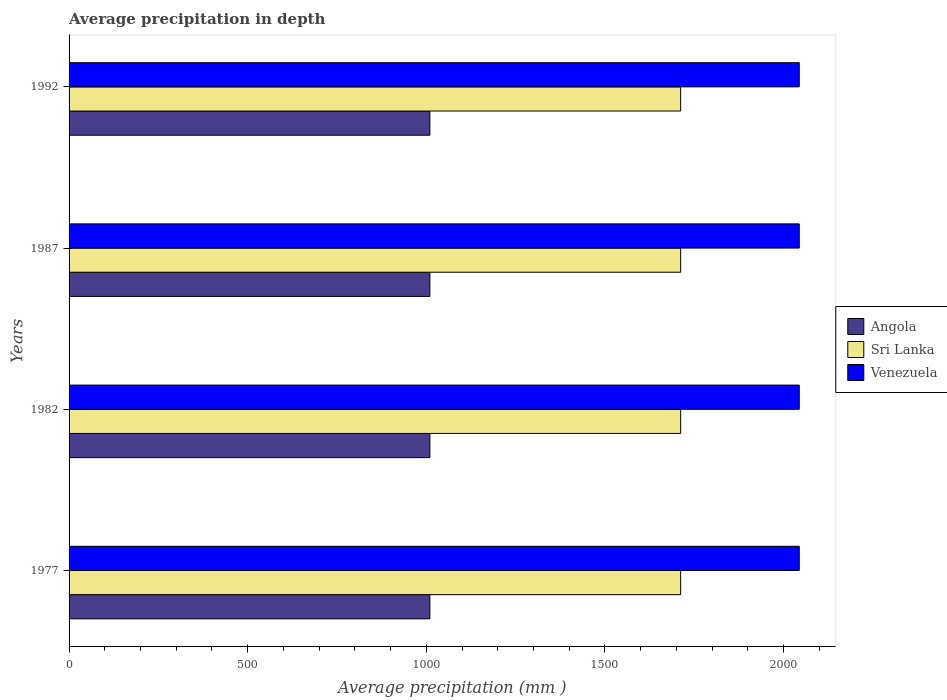How many different coloured bars are there?
Your answer should be very brief. 3. How many groups of bars are there?
Your response must be concise. 4. Are the number of bars per tick equal to the number of legend labels?
Give a very brief answer. Yes. How many bars are there on the 2nd tick from the top?
Offer a terse response. 3. How many bars are there on the 2nd tick from the bottom?
Ensure brevity in your answer.  3. What is the label of the 3rd group of bars from the top?
Give a very brief answer. 1982. What is the average precipitation in Venezuela in 1977?
Provide a succinct answer. 2044. Across all years, what is the maximum average precipitation in Angola?
Ensure brevity in your answer.  1010. Across all years, what is the minimum average precipitation in Venezuela?
Offer a very short reply. 2044. What is the total average precipitation in Sri Lanka in the graph?
Provide a succinct answer. 6848. What is the difference between the average precipitation in Angola in 1982 and that in 1987?
Ensure brevity in your answer.  0. What is the difference between the average precipitation in Sri Lanka in 1992 and the average precipitation in Angola in 1982?
Your response must be concise. 702. What is the average average precipitation in Venezuela per year?
Your response must be concise. 2044. In the year 1977, what is the difference between the average precipitation in Venezuela and average precipitation in Angola?
Your answer should be compact. 1034. In how many years, is the average precipitation in Sri Lanka greater than 200 mm?
Ensure brevity in your answer.  4. Is the average precipitation in Angola in 1987 less than that in 1992?
Give a very brief answer. No. What does the 1st bar from the top in 1992 represents?
Ensure brevity in your answer.  Venezuela. What does the 1st bar from the bottom in 1982 represents?
Ensure brevity in your answer.  Angola. Is it the case that in every year, the sum of the average precipitation in Angola and average precipitation in Venezuela is greater than the average precipitation in Sri Lanka?
Offer a very short reply. Yes. How many years are there in the graph?
Your answer should be compact. 4. What is the difference between two consecutive major ticks on the X-axis?
Ensure brevity in your answer.  500. Are the values on the major ticks of X-axis written in scientific E-notation?
Your response must be concise. No. Does the graph contain grids?
Your response must be concise. No. How many legend labels are there?
Offer a terse response. 3. What is the title of the graph?
Offer a terse response. Average precipitation in depth. What is the label or title of the X-axis?
Your answer should be very brief. Average precipitation (mm ). What is the label or title of the Y-axis?
Ensure brevity in your answer.  Years. What is the Average precipitation (mm ) of Angola in 1977?
Ensure brevity in your answer.  1010. What is the Average precipitation (mm ) of Sri Lanka in 1977?
Make the answer very short. 1712. What is the Average precipitation (mm ) in Venezuela in 1977?
Make the answer very short. 2044. What is the Average precipitation (mm ) in Angola in 1982?
Your response must be concise. 1010. What is the Average precipitation (mm ) in Sri Lanka in 1982?
Offer a very short reply. 1712. What is the Average precipitation (mm ) in Venezuela in 1982?
Your response must be concise. 2044. What is the Average precipitation (mm ) in Angola in 1987?
Provide a succinct answer. 1010. What is the Average precipitation (mm ) of Sri Lanka in 1987?
Your answer should be very brief. 1712. What is the Average precipitation (mm ) in Venezuela in 1987?
Your answer should be compact. 2044. What is the Average precipitation (mm ) in Angola in 1992?
Provide a short and direct response. 1010. What is the Average precipitation (mm ) of Sri Lanka in 1992?
Provide a short and direct response. 1712. What is the Average precipitation (mm ) in Venezuela in 1992?
Keep it short and to the point. 2044. Across all years, what is the maximum Average precipitation (mm ) of Angola?
Provide a short and direct response. 1010. Across all years, what is the maximum Average precipitation (mm ) in Sri Lanka?
Offer a very short reply. 1712. Across all years, what is the maximum Average precipitation (mm ) in Venezuela?
Your response must be concise. 2044. Across all years, what is the minimum Average precipitation (mm ) in Angola?
Give a very brief answer. 1010. Across all years, what is the minimum Average precipitation (mm ) of Sri Lanka?
Offer a very short reply. 1712. Across all years, what is the minimum Average precipitation (mm ) in Venezuela?
Your answer should be very brief. 2044. What is the total Average precipitation (mm ) of Angola in the graph?
Offer a terse response. 4040. What is the total Average precipitation (mm ) in Sri Lanka in the graph?
Make the answer very short. 6848. What is the total Average precipitation (mm ) in Venezuela in the graph?
Keep it short and to the point. 8176. What is the difference between the Average precipitation (mm ) in Venezuela in 1977 and that in 1982?
Your response must be concise. 0. What is the difference between the Average precipitation (mm ) of Angola in 1977 and that in 1987?
Your answer should be very brief. 0. What is the difference between the Average precipitation (mm ) of Venezuela in 1977 and that in 1987?
Your answer should be very brief. 0. What is the difference between the Average precipitation (mm ) of Venezuela in 1977 and that in 1992?
Your answer should be very brief. 0. What is the difference between the Average precipitation (mm ) in Sri Lanka in 1982 and that in 1992?
Your answer should be compact. 0. What is the difference between the Average precipitation (mm ) in Venezuela in 1982 and that in 1992?
Provide a short and direct response. 0. What is the difference between the Average precipitation (mm ) of Angola in 1987 and that in 1992?
Your answer should be compact. 0. What is the difference between the Average precipitation (mm ) in Sri Lanka in 1987 and that in 1992?
Your response must be concise. 0. What is the difference between the Average precipitation (mm ) in Venezuela in 1987 and that in 1992?
Offer a very short reply. 0. What is the difference between the Average precipitation (mm ) in Angola in 1977 and the Average precipitation (mm ) in Sri Lanka in 1982?
Give a very brief answer. -702. What is the difference between the Average precipitation (mm ) of Angola in 1977 and the Average precipitation (mm ) of Venezuela in 1982?
Offer a terse response. -1034. What is the difference between the Average precipitation (mm ) of Sri Lanka in 1977 and the Average precipitation (mm ) of Venezuela in 1982?
Your answer should be very brief. -332. What is the difference between the Average precipitation (mm ) in Angola in 1977 and the Average precipitation (mm ) in Sri Lanka in 1987?
Offer a very short reply. -702. What is the difference between the Average precipitation (mm ) in Angola in 1977 and the Average precipitation (mm ) in Venezuela in 1987?
Offer a terse response. -1034. What is the difference between the Average precipitation (mm ) in Sri Lanka in 1977 and the Average precipitation (mm ) in Venezuela in 1987?
Provide a short and direct response. -332. What is the difference between the Average precipitation (mm ) in Angola in 1977 and the Average precipitation (mm ) in Sri Lanka in 1992?
Offer a terse response. -702. What is the difference between the Average precipitation (mm ) in Angola in 1977 and the Average precipitation (mm ) in Venezuela in 1992?
Your answer should be compact. -1034. What is the difference between the Average precipitation (mm ) of Sri Lanka in 1977 and the Average precipitation (mm ) of Venezuela in 1992?
Give a very brief answer. -332. What is the difference between the Average precipitation (mm ) in Angola in 1982 and the Average precipitation (mm ) in Sri Lanka in 1987?
Your answer should be compact. -702. What is the difference between the Average precipitation (mm ) of Angola in 1982 and the Average precipitation (mm ) of Venezuela in 1987?
Keep it short and to the point. -1034. What is the difference between the Average precipitation (mm ) in Sri Lanka in 1982 and the Average precipitation (mm ) in Venezuela in 1987?
Provide a succinct answer. -332. What is the difference between the Average precipitation (mm ) of Angola in 1982 and the Average precipitation (mm ) of Sri Lanka in 1992?
Give a very brief answer. -702. What is the difference between the Average precipitation (mm ) of Angola in 1982 and the Average precipitation (mm ) of Venezuela in 1992?
Your answer should be compact. -1034. What is the difference between the Average precipitation (mm ) of Sri Lanka in 1982 and the Average precipitation (mm ) of Venezuela in 1992?
Your answer should be compact. -332. What is the difference between the Average precipitation (mm ) of Angola in 1987 and the Average precipitation (mm ) of Sri Lanka in 1992?
Your answer should be very brief. -702. What is the difference between the Average precipitation (mm ) of Angola in 1987 and the Average precipitation (mm ) of Venezuela in 1992?
Offer a terse response. -1034. What is the difference between the Average precipitation (mm ) of Sri Lanka in 1987 and the Average precipitation (mm ) of Venezuela in 1992?
Your answer should be very brief. -332. What is the average Average precipitation (mm ) of Angola per year?
Keep it short and to the point. 1010. What is the average Average precipitation (mm ) in Sri Lanka per year?
Provide a short and direct response. 1712. What is the average Average precipitation (mm ) of Venezuela per year?
Your answer should be compact. 2044. In the year 1977, what is the difference between the Average precipitation (mm ) in Angola and Average precipitation (mm ) in Sri Lanka?
Provide a succinct answer. -702. In the year 1977, what is the difference between the Average precipitation (mm ) in Angola and Average precipitation (mm ) in Venezuela?
Your answer should be very brief. -1034. In the year 1977, what is the difference between the Average precipitation (mm ) of Sri Lanka and Average precipitation (mm ) of Venezuela?
Your answer should be very brief. -332. In the year 1982, what is the difference between the Average precipitation (mm ) in Angola and Average precipitation (mm ) in Sri Lanka?
Your answer should be compact. -702. In the year 1982, what is the difference between the Average precipitation (mm ) of Angola and Average precipitation (mm ) of Venezuela?
Give a very brief answer. -1034. In the year 1982, what is the difference between the Average precipitation (mm ) in Sri Lanka and Average precipitation (mm ) in Venezuela?
Your answer should be compact. -332. In the year 1987, what is the difference between the Average precipitation (mm ) in Angola and Average precipitation (mm ) in Sri Lanka?
Offer a terse response. -702. In the year 1987, what is the difference between the Average precipitation (mm ) of Angola and Average precipitation (mm ) of Venezuela?
Provide a short and direct response. -1034. In the year 1987, what is the difference between the Average precipitation (mm ) of Sri Lanka and Average precipitation (mm ) of Venezuela?
Offer a terse response. -332. In the year 1992, what is the difference between the Average precipitation (mm ) in Angola and Average precipitation (mm ) in Sri Lanka?
Your answer should be very brief. -702. In the year 1992, what is the difference between the Average precipitation (mm ) of Angola and Average precipitation (mm ) of Venezuela?
Your answer should be compact. -1034. In the year 1992, what is the difference between the Average precipitation (mm ) in Sri Lanka and Average precipitation (mm ) in Venezuela?
Your answer should be very brief. -332. What is the ratio of the Average precipitation (mm ) in Sri Lanka in 1977 to that in 1982?
Provide a short and direct response. 1. What is the ratio of the Average precipitation (mm ) in Venezuela in 1977 to that in 1982?
Provide a short and direct response. 1. What is the ratio of the Average precipitation (mm ) in Sri Lanka in 1977 to that in 1987?
Your response must be concise. 1. What is the ratio of the Average precipitation (mm ) in Sri Lanka in 1977 to that in 1992?
Keep it short and to the point. 1. What is the ratio of the Average precipitation (mm ) in Angola in 1982 to that in 1987?
Keep it short and to the point. 1. What is the ratio of the Average precipitation (mm ) of Angola in 1982 to that in 1992?
Ensure brevity in your answer.  1. What is the ratio of the Average precipitation (mm ) in Venezuela in 1982 to that in 1992?
Your answer should be compact. 1. What is the ratio of the Average precipitation (mm ) of Angola in 1987 to that in 1992?
Provide a succinct answer. 1. What is the ratio of the Average precipitation (mm ) of Sri Lanka in 1987 to that in 1992?
Give a very brief answer. 1. What is the difference between the highest and the second highest Average precipitation (mm ) of Sri Lanka?
Offer a terse response. 0. What is the difference between the highest and the second highest Average precipitation (mm ) in Venezuela?
Provide a succinct answer. 0. What is the difference between the highest and the lowest Average precipitation (mm ) of Venezuela?
Ensure brevity in your answer.  0. 